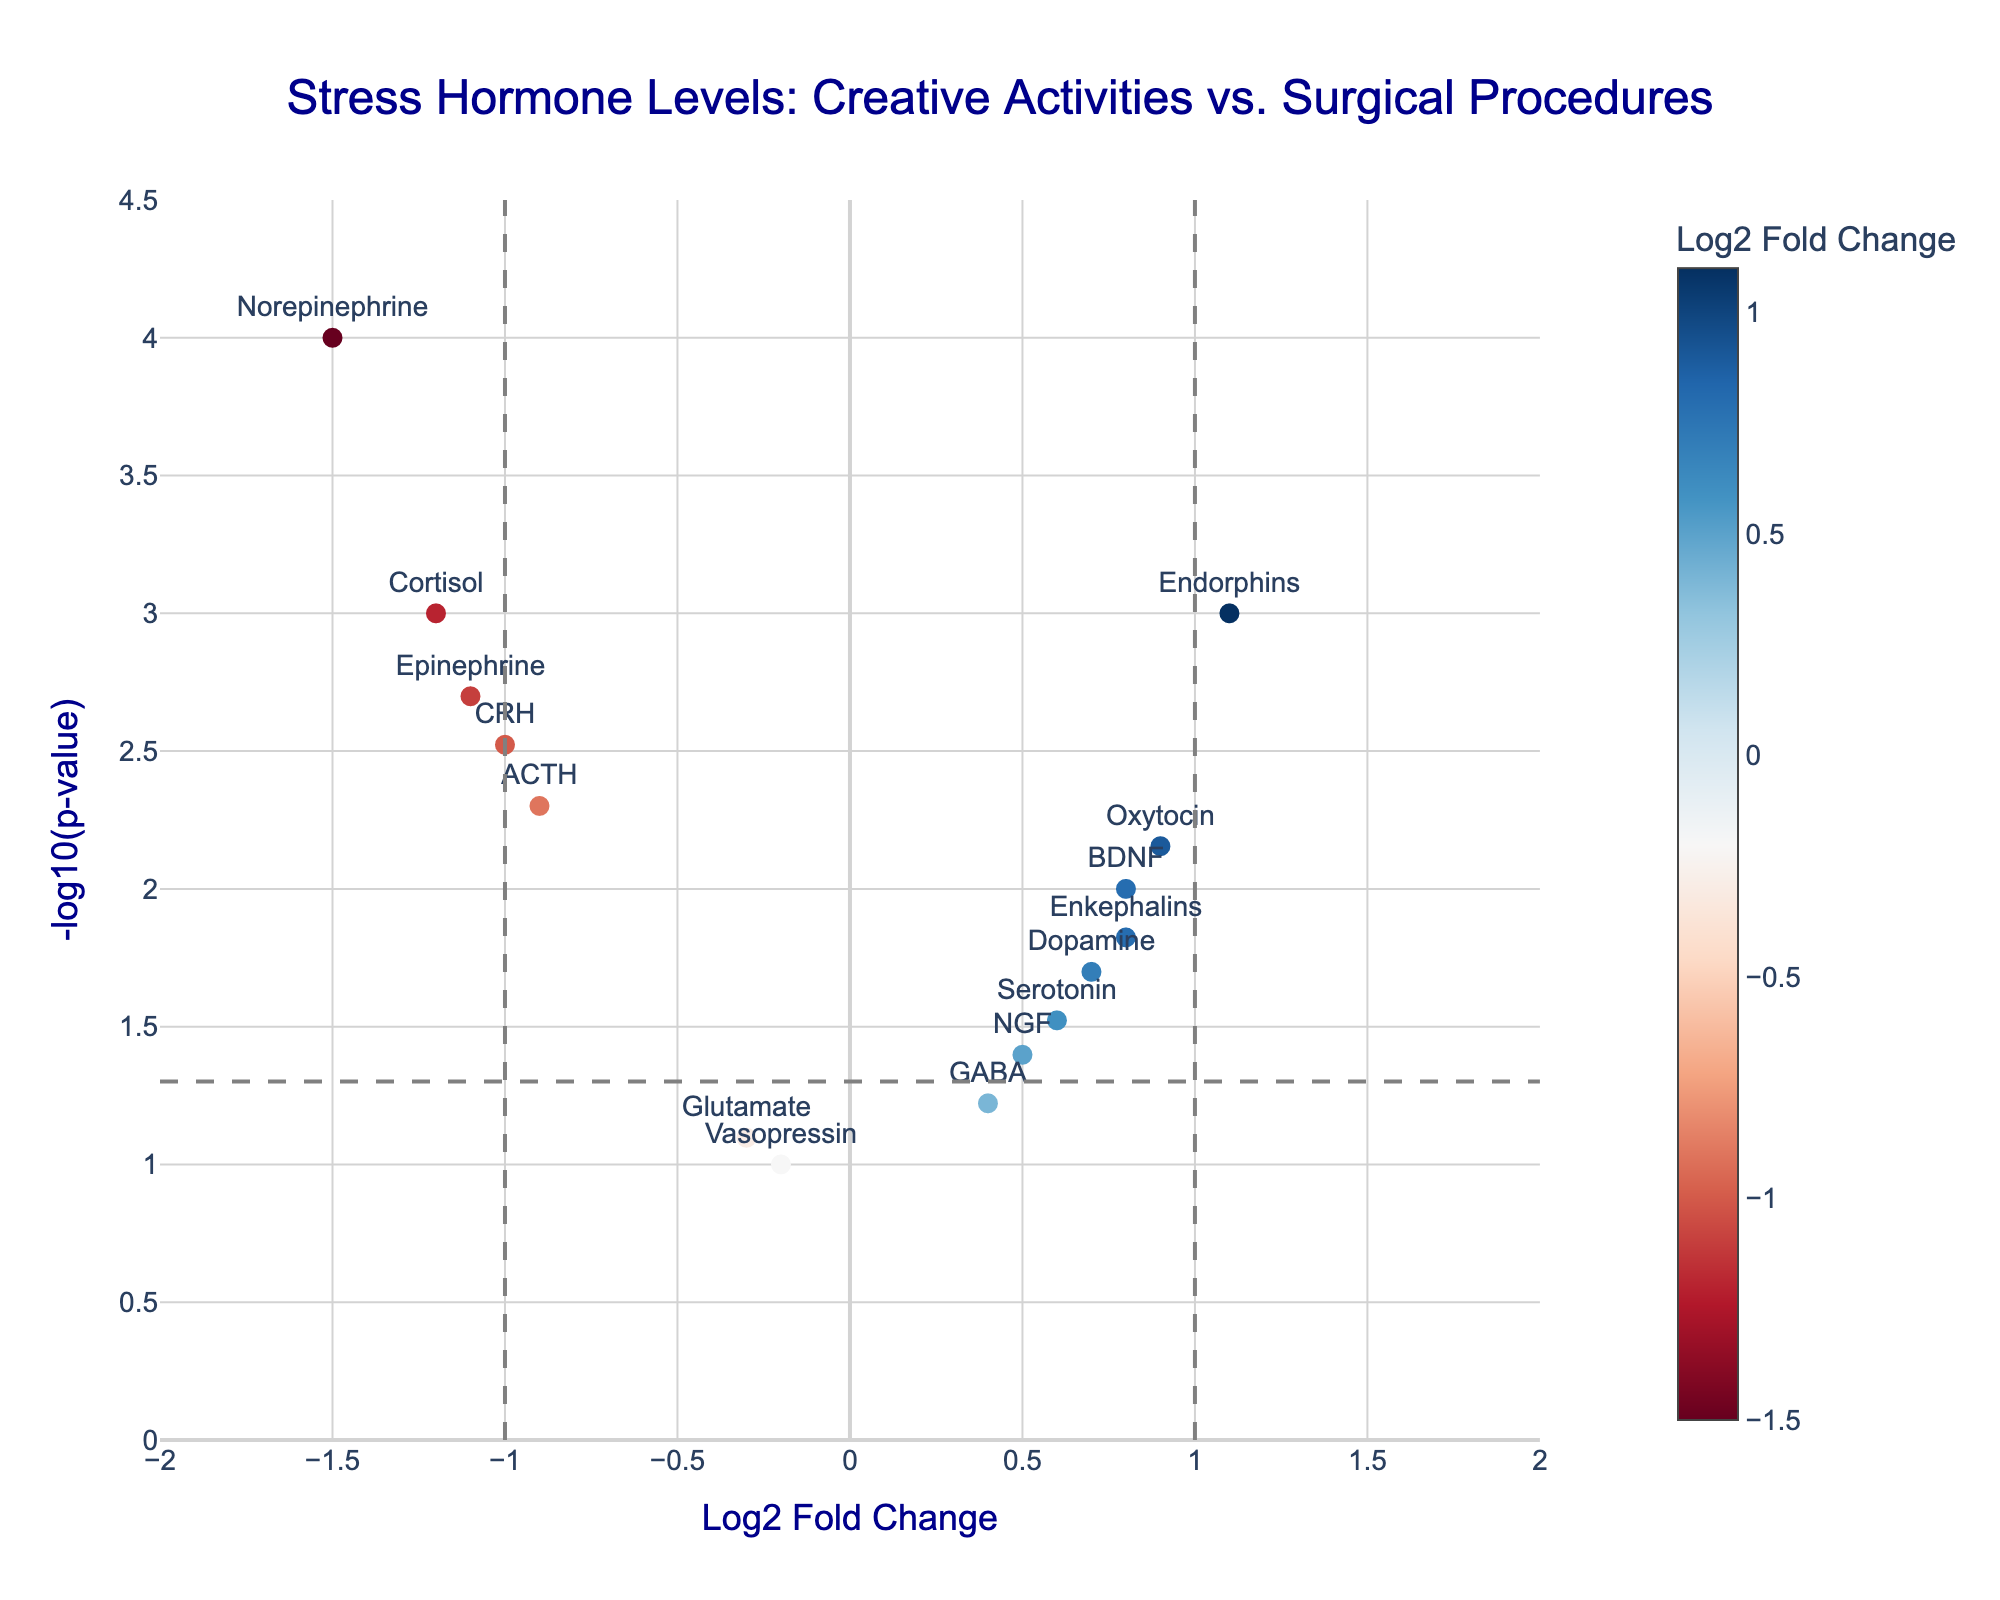What is the title of the figure? The title is usually at the top of the figure. We read the text placed there, which states "Stress Hormone Levels: Creative Activities vs. Surgical Procedures".
Answer: Stress Hormone Levels: Creative Activities vs. Surgical Procedures How many genes have a positive Log2 Fold Change? By counting the number of points above x=0, we find the genes with positive Log2 Fold Change.
Answer: 8 What is the p-value threshold used in the plot? There is a horizontal dashed line indicating the significance threshold for p-values. The y-axis value of this line corresponds to -log10(0.05).
Answer: 0.05 Which gene has the highest Log2 Fold Change? Look for the point farthest to the right. The gene associated with that point is "Endorphins".
Answer: Endorphins Which gene has the most significant p-value (smallest p-value)? The gene with the highest y value in the plot represents the most significant p-value. This is "Norepinephrine".
Answer: Norepinephrine How many genes are both significantly different and have a positive Log2 Fold Change? Genes with a p-value less than 0.05 and positive Log2 Fold Change are the points above the dashed horizontal line and to the right of x=0. We count these points.
Answer: 5 Is there any gene with a negative Log2 Fold Change and a non-significant p-value? Look for points to the left of x=0 and below the horizontal dashed line representing the p-value threshold. "Vasopressin" fits this criteria.
Answer: Yes, Vasopressin Which genes show a significant decrease in stress hormone levels after creative activities compared to surgical procedures? Genes with negative Log2 Fold Change and p-value less than 0.05 are visualized as points to the left of x=-0 and above the horizontal dashed line. These include "Cortisol", "ACTH", "Norepinephrine", "Epinephrine", and "CRH".
Answer: Cortisol, ACTH, Norepinephrine, Epinephrine, CRH What's the range of Log2 Fold Change values? The range is determined by the x-axis limits set on the plot, which span from -2 to +2.
Answer: -2 to 2 